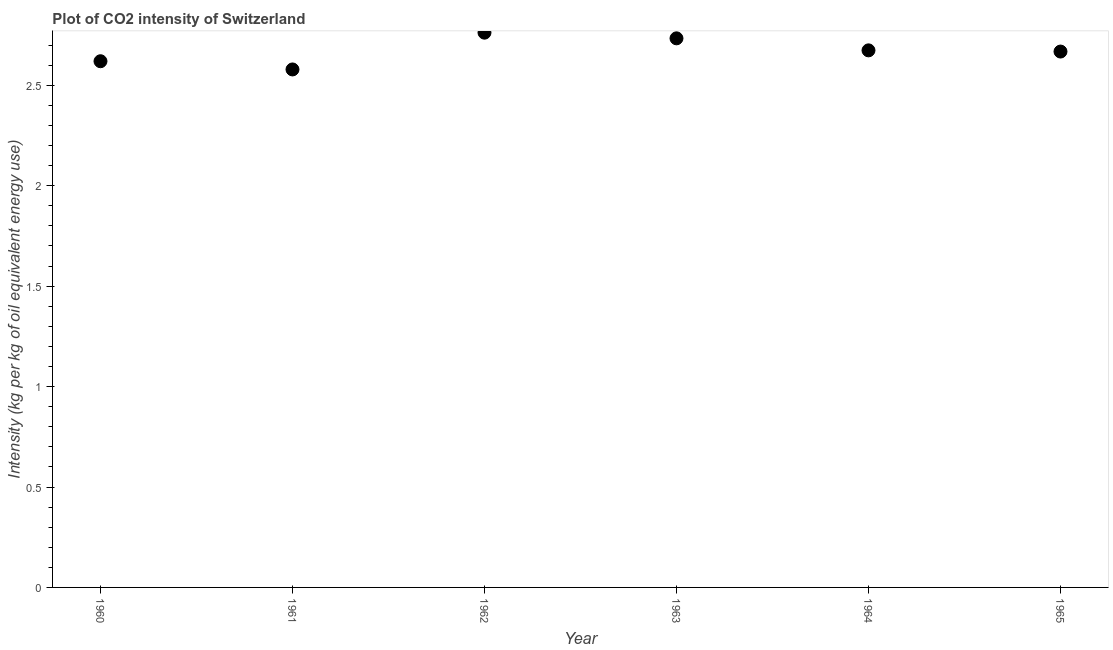What is the co2 intensity in 1963?
Your response must be concise. 2.73. Across all years, what is the maximum co2 intensity?
Your answer should be very brief. 2.76. Across all years, what is the minimum co2 intensity?
Make the answer very short. 2.58. What is the sum of the co2 intensity?
Provide a succinct answer. 16.04. What is the difference between the co2 intensity in 1962 and 1965?
Your answer should be very brief. 0.09. What is the average co2 intensity per year?
Make the answer very short. 2.67. What is the median co2 intensity?
Provide a succinct answer. 2.67. In how many years, is the co2 intensity greater than 0.6 kg?
Your response must be concise. 6. Do a majority of the years between 1963 and 1960 (inclusive) have co2 intensity greater than 1.7 kg?
Offer a very short reply. Yes. What is the ratio of the co2 intensity in 1964 to that in 1965?
Provide a succinct answer. 1. What is the difference between the highest and the second highest co2 intensity?
Make the answer very short. 0.03. What is the difference between the highest and the lowest co2 intensity?
Ensure brevity in your answer.  0.18. In how many years, is the co2 intensity greater than the average co2 intensity taken over all years?
Offer a very short reply. 3. Does the co2 intensity monotonically increase over the years?
Keep it short and to the point. No. How many dotlines are there?
Offer a terse response. 1. How many years are there in the graph?
Provide a short and direct response. 6. Does the graph contain grids?
Offer a terse response. No. What is the title of the graph?
Your answer should be very brief. Plot of CO2 intensity of Switzerland. What is the label or title of the X-axis?
Provide a short and direct response. Year. What is the label or title of the Y-axis?
Offer a terse response. Intensity (kg per kg of oil equivalent energy use). What is the Intensity (kg per kg of oil equivalent energy use) in 1960?
Your response must be concise. 2.62. What is the Intensity (kg per kg of oil equivalent energy use) in 1961?
Your response must be concise. 2.58. What is the Intensity (kg per kg of oil equivalent energy use) in 1962?
Your answer should be very brief. 2.76. What is the Intensity (kg per kg of oil equivalent energy use) in 1963?
Give a very brief answer. 2.73. What is the Intensity (kg per kg of oil equivalent energy use) in 1964?
Your answer should be very brief. 2.67. What is the Intensity (kg per kg of oil equivalent energy use) in 1965?
Provide a short and direct response. 2.67. What is the difference between the Intensity (kg per kg of oil equivalent energy use) in 1960 and 1961?
Your answer should be very brief. 0.04. What is the difference between the Intensity (kg per kg of oil equivalent energy use) in 1960 and 1962?
Provide a short and direct response. -0.14. What is the difference between the Intensity (kg per kg of oil equivalent energy use) in 1960 and 1963?
Your response must be concise. -0.11. What is the difference between the Intensity (kg per kg of oil equivalent energy use) in 1960 and 1964?
Your response must be concise. -0.05. What is the difference between the Intensity (kg per kg of oil equivalent energy use) in 1960 and 1965?
Provide a succinct answer. -0.05. What is the difference between the Intensity (kg per kg of oil equivalent energy use) in 1961 and 1962?
Your answer should be compact. -0.18. What is the difference between the Intensity (kg per kg of oil equivalent energy use) in 1961 and 1963?
Keep it short and to the point. -0.15. What is the difference between the Intensity (kg per kg of oil equivalent energy use) in 1961 and 1964?
Provide a short and direct response. -0.1. What is the difference between the Intensity (kg per kg of oil equivalent energy use) in 1961 and 1965?
Your answer should be compact. -0.09. What is the difference between the Intensity (kg per kg of oil equivalent energy use) in 1962 and 1963?
Ensure brevity in your answer.  0.03. What is the difference between the Intensity (kg per kg of oil equivalent energy use) in 1962 and 1964?
Provide a short and direct response. 0.09. What is the difference between the Intensity (kg per kg of oil equivalent energy use) in 1962 and 1965?
Offer a very short reply. 0.09. What is the difference between the Intensity (kg per kg of oil equivalent energy use) in 1963 and 1964?
Provide a succinct answer. 0.06. What is the difference between the Intensity (kg per kg of oil equivalent energy use) in 1963 and 1965?
Ensure brevity in your answer.  0.07. What is the difference between the Intensity (kg per kg of oil equivalent energy use) in 1964 and 1965?
Give a very brief answer. 0.01. What is the ratio of the Intensity (kg per kg of oil equivalent energy use) in 1960 to that in 1961?
Your response must be concise. 1.02. What is the ratio of the Intensity (kg per kg of oil equivalent energy use) in 1960 to that in 1962?
Ensure brevity in your answer.  0.95. What is the ratio of the Intensity (kg per kg of oil equivalent energy use) in 1960 to that in 1963?
Your answer should be very brief. 0.96. What is the ratio of the Intensity (kg per kg of oil equivalent energy use) in 1960 to that in 1964?
Your answer should be very brief. 0.98. What is the ratio of the Intensity (kg per kg of oil equivalent energy use) in 1961 to that in 1962?
Provide a succinct answer. 0.93. What is the ratio of the Intensity (kg per kg of oil equivalent energy use) in 1961 to that in 1963?
Your response must be concise. 0.94. What is the ratio of the Intensity (kg per kg of oil equivalent energy use) in 1961 to that in 1964?
Your answer should be very brief. 0.96. What is the ratio of the Intensity (kg per kg of oil equivalent energy use) in 1961 to that in 1965?
Provide a short and direct response. 0.97. What is the ratio of the Intensity (kg per kg of oil equivalent energy use) in 1962 to that in 1963?
Make the answer very short. 1.01. What is the ratio of the Intensity (kg per kg of oil equivalent energy use) in 1962 to that in 1964?
Your answer should be compact. 1.03. What is the ratio of the Intensity (kg per kg of oil equivalent energy use) in 1962 to that in 1965?
Provide a short and direct response. 1.03. What is the ratio of the Intensity (kg per kg of oil equivalent energy use) in 1963 to that in 1965?
Your response must be concise. 1.02. What is the ratio of the Intensity (kg per kg of oil equivalent energy use) in 1964 to that in 1965?
Your answer should be very brief. 1. 